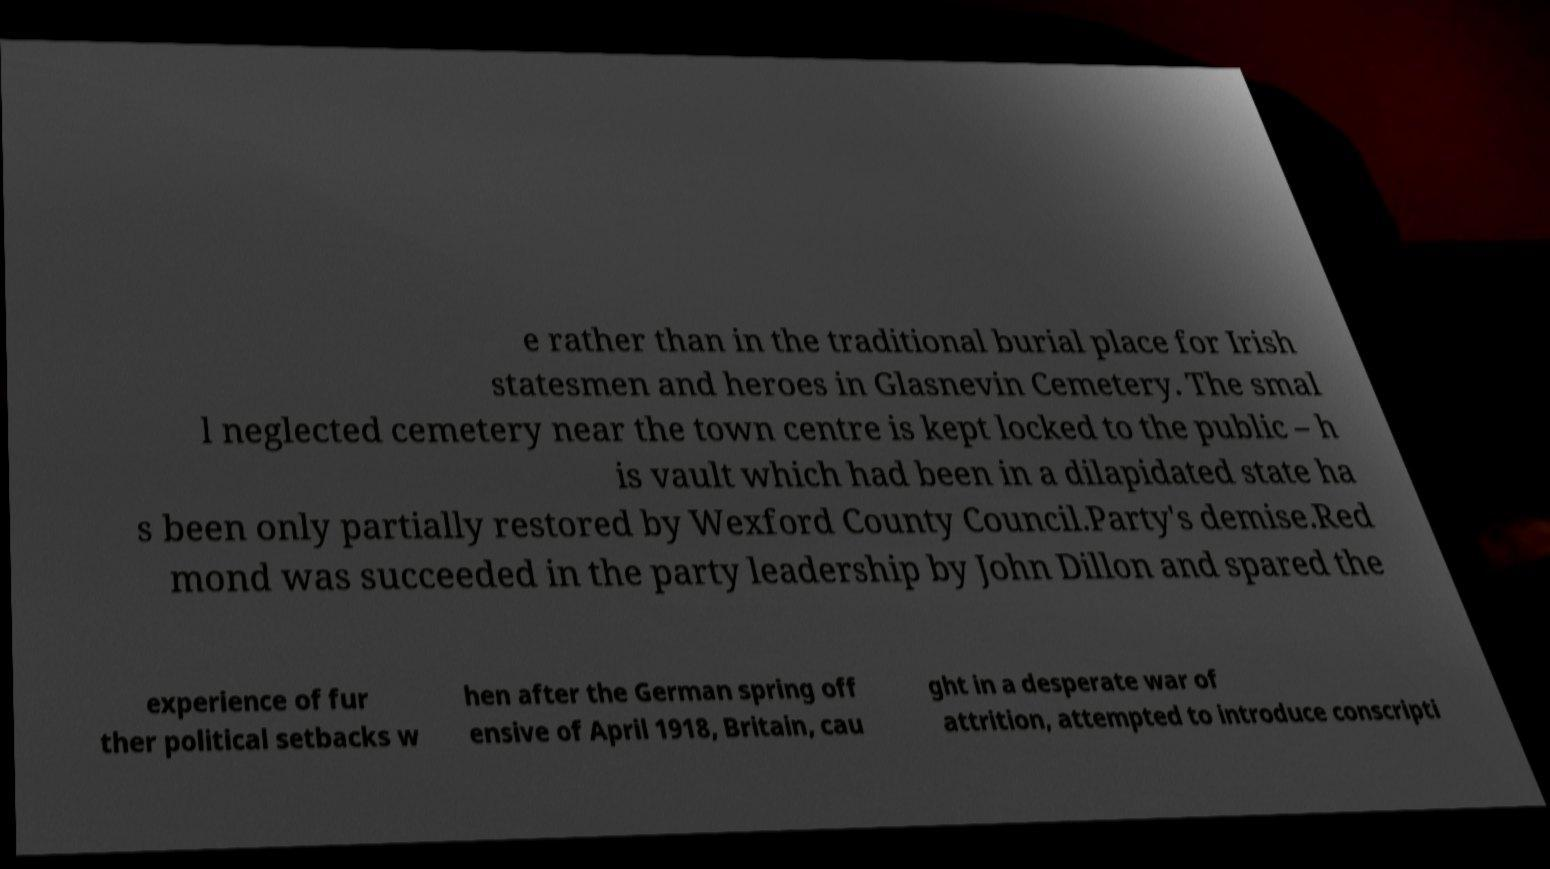Can you accurately transcribe the text from the provided image for me? e rather than in the traditional burial place for Irish statesmen and heroes in Glasnevin Cemetery. The smal l neglected cemetery near the town centre is kept locked to the public – h is vault which had been in a dilapidated state ha s been only partially restored by Wexford County Council.Party's demise.Red mond was succeeded in the party leadership by John Dillon and spared the experience of fur ther political setbacks w hen after the German spring off ensive of April 1918, Britain, cau ght in a desperate war of attrition, attempted to introduce conscripti 